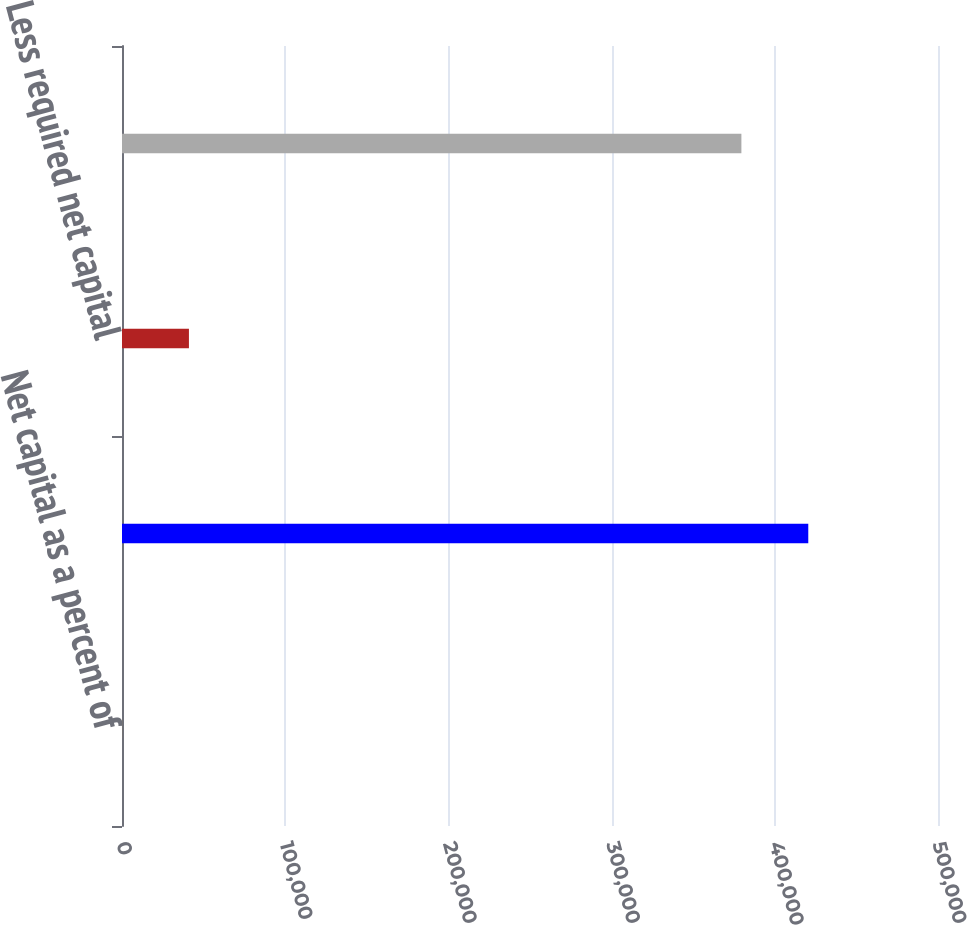<chart> <loc_0><loc_0><loc_500><loc_500><bar_chart><fcel>Net capital as a percent of<fcel>Net capital<fcel>Less required net capital<fcel>Excess net capital<nl><fcel>27.02<fcel>420513<fcel>41011.2<fcel>379529<nl></chart> 